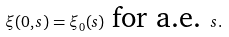Convert formula to latex. <formula><loc_0><loc_0><loc_500><loc_500>\xi ( 0 , s ) = \xi _ { 0 } ( s ) \text { for a.e. } s .</formula> 